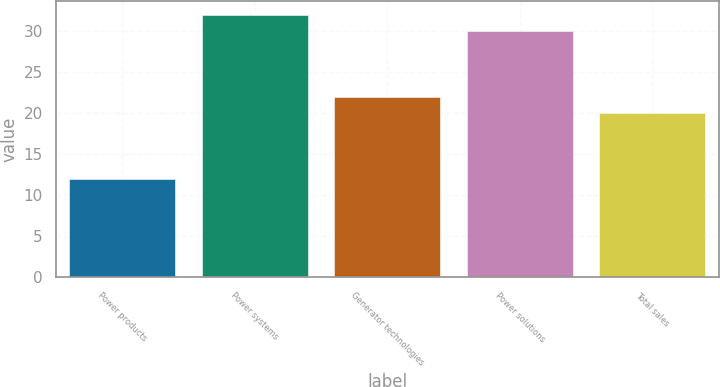Convert chart. <chart><loc_0><loc_0><loc_500><loc_500><bar_chart><fcel>Power products<fcel>Power systems<fcel>Generator technologies<fcel>Power solutions<fcel>Total sales<nl><fcel>12<fcel>32<fcel>22<fcel>30<fcel>20<nl></chart> 